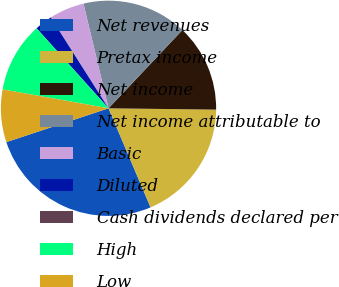Convert chart. <chart><loc_0><loc_0><loc_500><loc_500><pie_chart><fcel>Net revenues<fcel>Pretax income<fcel>Net income<fcel>Net income attributable to<fcel>Basic<fcel>Diluted<fcel>Cash dividends declared per<fcel>High<fcel>Low<nl><fcel>26.31%<fcel>18.42%<fcel>13.16%<fcel>15.79%<fcel>5.27%<fcel>2.64%<fcel>0.01%<fcel>10.53%<fcel>7.9%<nl></chart> 